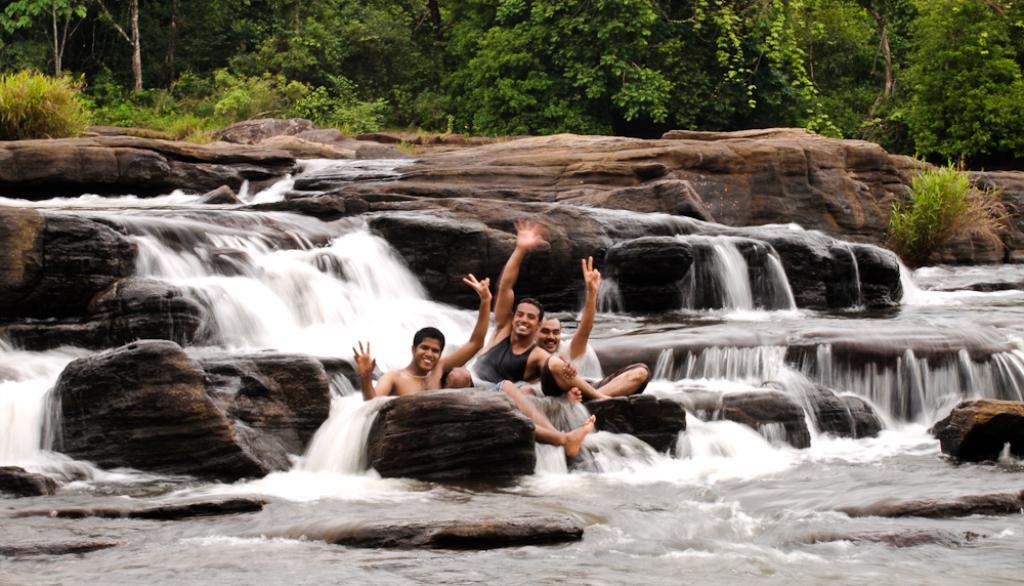What type of natural elements can be seen in the background of the image? There are trees, plants, a waterfall, and rocks in the background of the image. What are the men in the image doing? The men in the image are posing. How are the men feeling in the image? The men are smiling in the image. Can you see any geese flying over the waterfall in the image? There are no geese visible in the image; it features trees, plants, a waterfall, and rocks in the background. What type of net is being used by the men in the image? There is no net present in the image; it features men posing and smiling in the background of natural elements. 